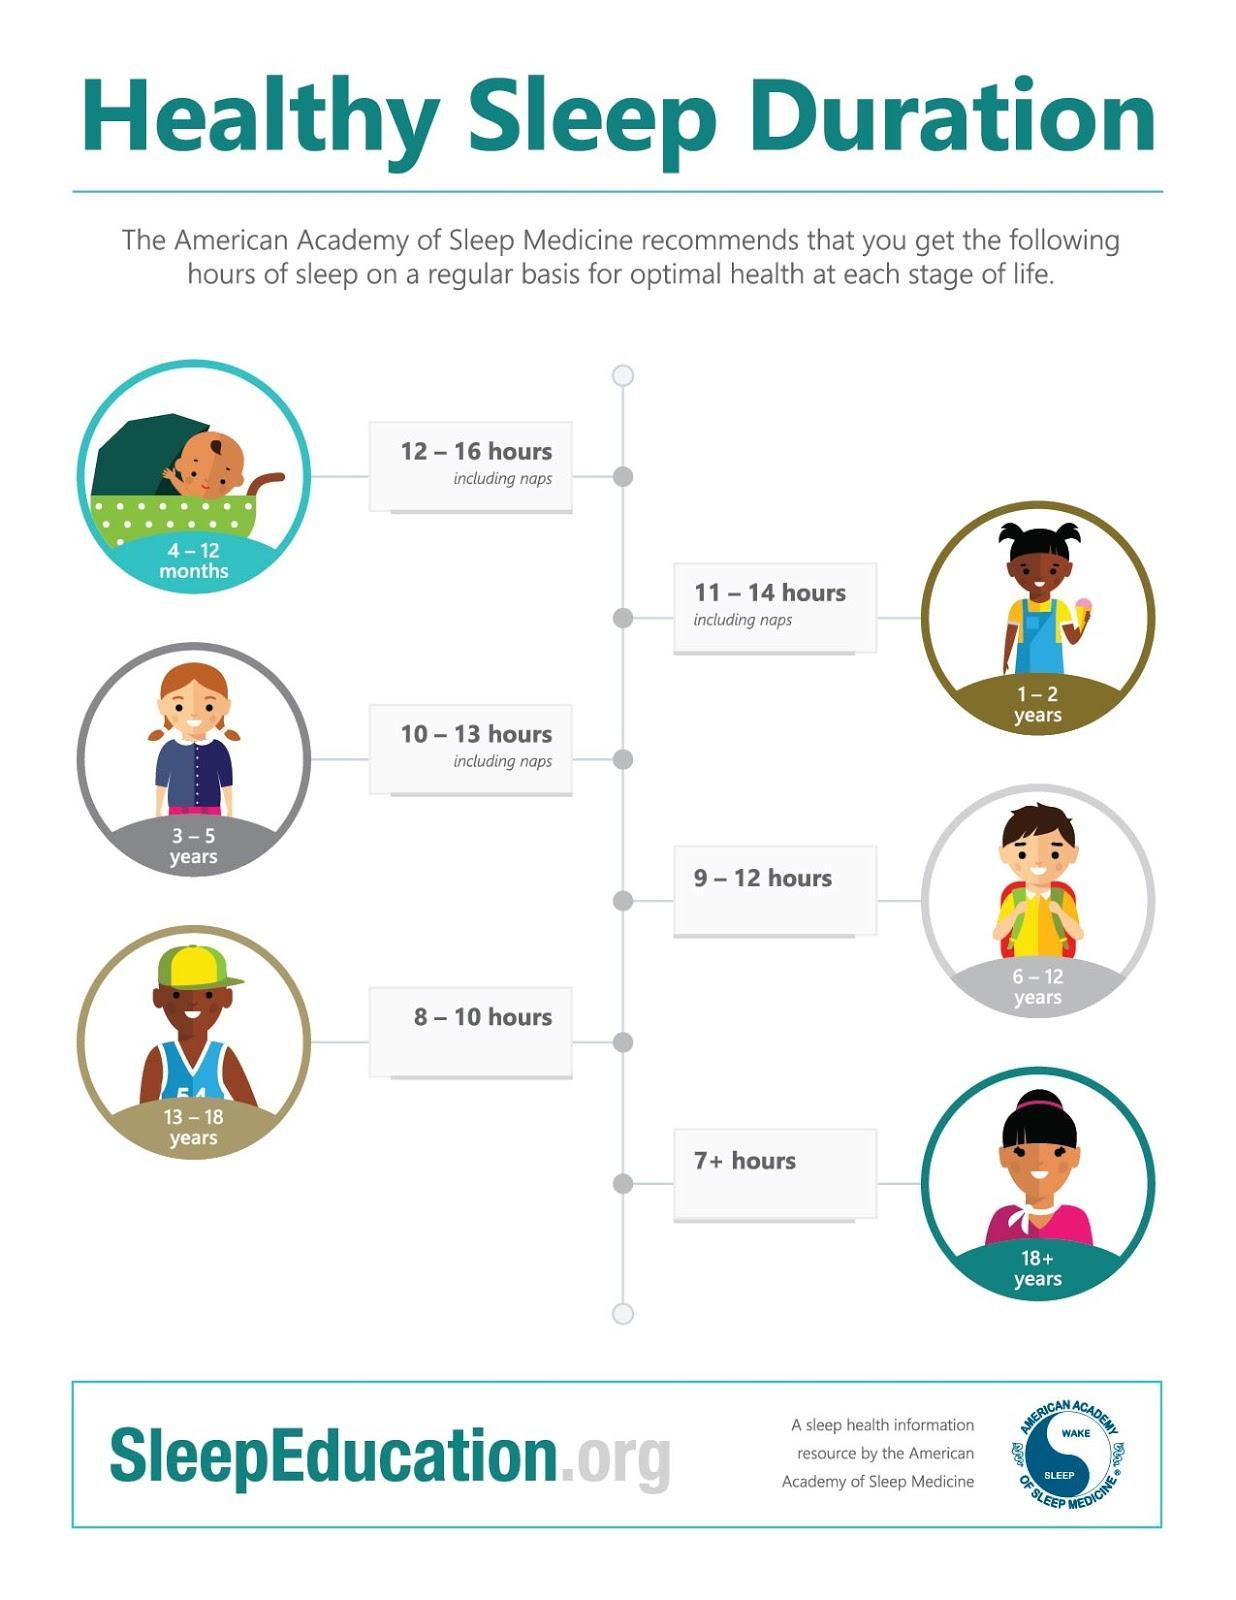Which age group should get 11-14 hours of sleep, 3-5 years, 4-12 months or 1-2 years?
Answer the question with a short phrase. 1-2 years What is the amount of sleep 13-18 year old should get, 9-12 hours, 8-10 hours, or 7+ hours? 8-10 hours 